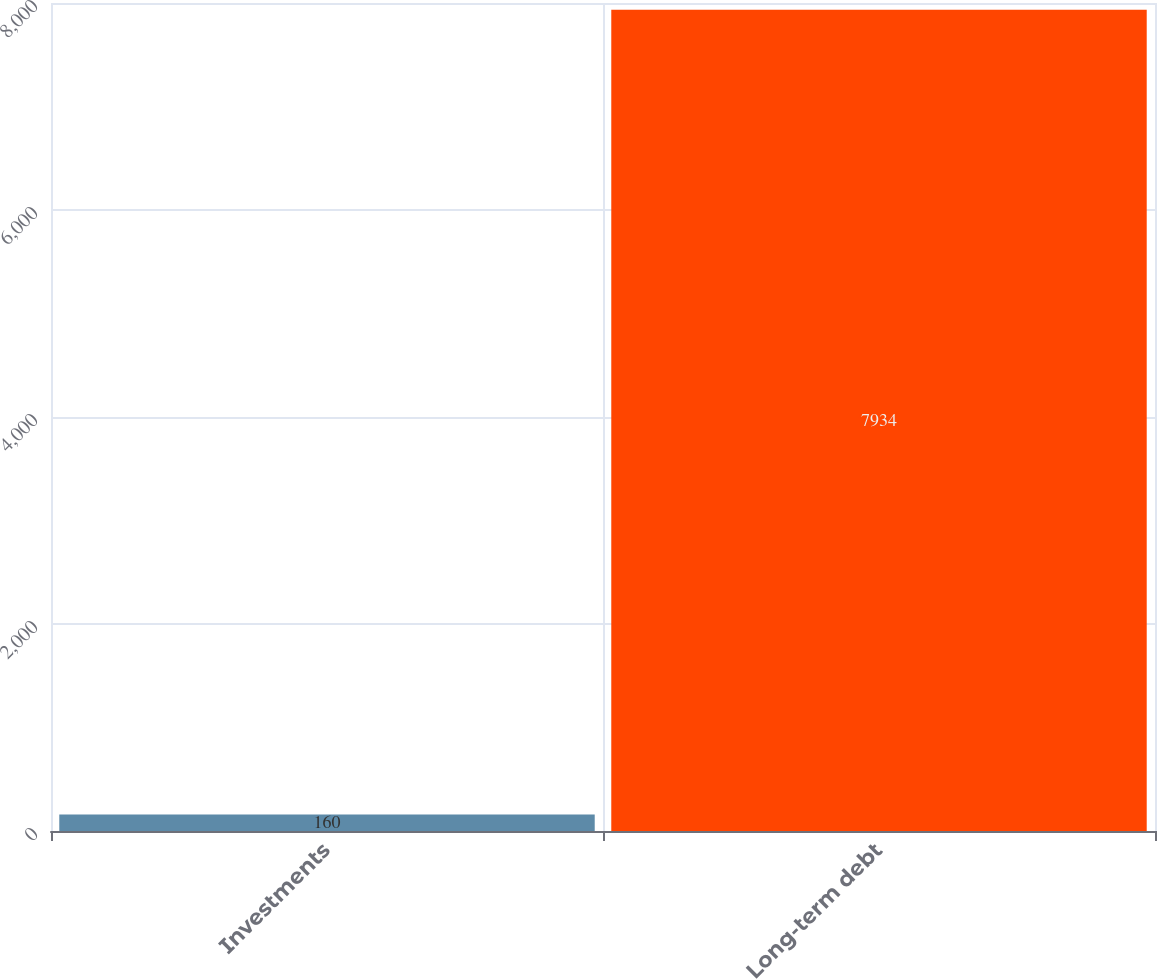<chart> <loc_0><loc_0><loc_500><loc_500><bar_chart><fcel>Investments<fcel>Long-term debt<nl><fcel>160<fcel>7934<nl></chart> 